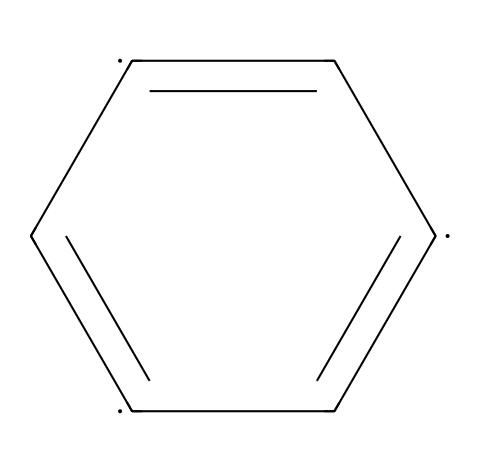What is the basic structural unit of graphene represented here? The structure given is that of a cyclic compound with alternating double bonds between carbon atoms, indicating that the basic structural unit is a carbon atom.
Answer: carbon How many carbon atoms are present in this structure? By examining the SMILES representation, it shows six carbon atoms connected in a planar arrangement, leading to the conclusion that there are six carbon atoms in total.
Answer: six What type of bonding is primarily found in the structure of graphene? The chemical contains alternating double bonds, which indicates that covalent bonding is primarily featured in graphene’s structure, characteristic of its strong connections between carbon atoms.
Answer: covalent How does the structure of graphene contribute to its high electrical conductivity? The alternating double bonds in this structure allow for the delocalization of electrons across the carbon network, which contributes to its high electrical conductivity.
Answer: delocalization Is this compound a two-dimensional material? Yes, the structure represents a flat arrangement of carbon atoms, typical of graphene, which confirms that it is indeed a two-dimensional material.
Answer: yes What is the bond angle between the carbon atoms in this structure? The angles between the carbon atoms connected in a planar structure like this are approximately 120 degrees due to sp2 hybridization, reflecting the geometry of the bonds.
Answer: 120 degrees What application of graphene aligns with its structure as shown here? The unique arrangement of carbon and its electrical properties enable graphene to be used in advanced touchscreen displays, showcasing its application in electronics.
Answer: touchscreen displays 